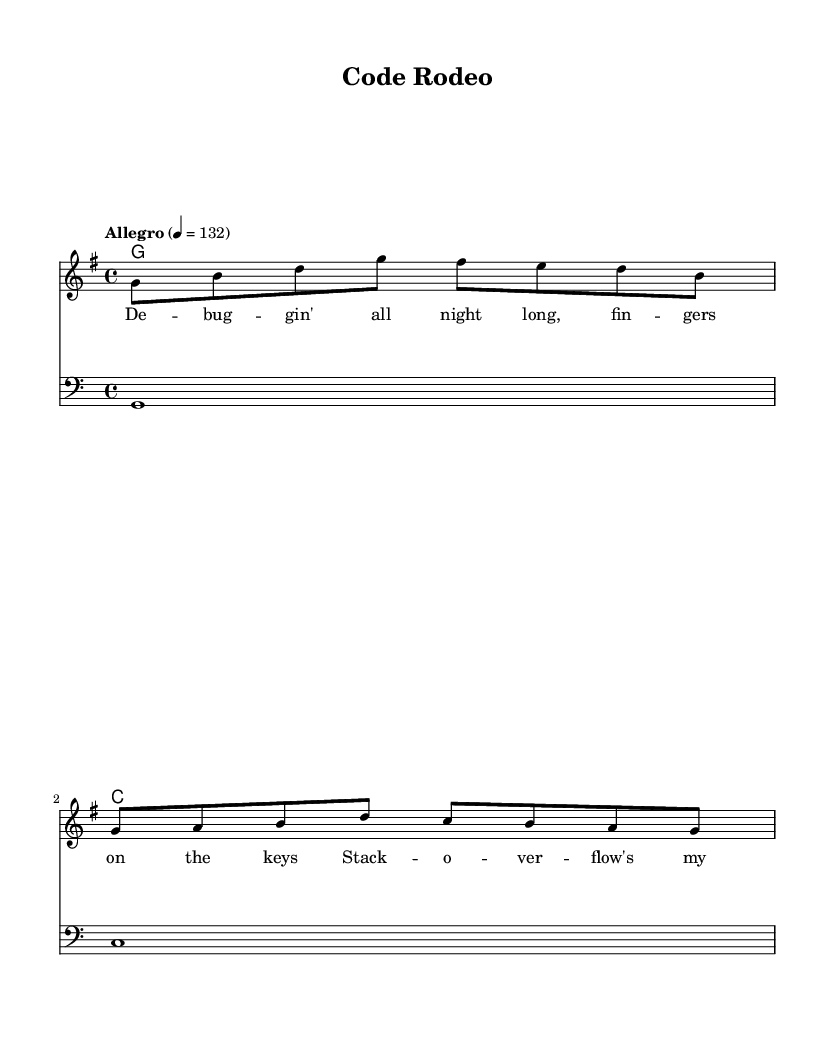What is the key signature of this music? The key signature is G major, which has one sharp (F#). This can be identified by looking at the key signature indicated at the beginning of the staff.
Answer: G major What is the time signature of this music? The time signature is 4/4, which is notated at the beginning of the piece. It signifies that there are four beats in each measure and the quarter note gets one beat.
Answer: 4/4 What is the tempo marking for this piece? The tempo marking indicates "Allegro" at a speed of quarter note = 132. This shows that the music should be played fast and lively.
Answer: Allegro 4 = 132 How many measures are in the melody? The melody is written in two measures, as observed by counting the vertical bar lines (which indicate the end of each measure) in the melody section.
Answer: 2 What is the main theme of the lyrics in this song? The lyrics reflect a theme of working on debugging, celebrating the experience of successful software development. This can be inferred from phrases like "de-buggin' all night long" and references to "Stack Overflow."
Answer: Debugging What chords are used in the harmony section? The harmony section consists of two chords: G major and C major. This is determined by examining the chord names notated in the chord mode beneath the staff.
Answer: G and C Is this piece playable for beginners? Yes, the piece consists of simple melodies, straightforward lyrics, and basic chords, making it accessible for beginners. This is clear from the simplicity and repetitiveness of the melodic line and chord changes.
Answer: Yes 